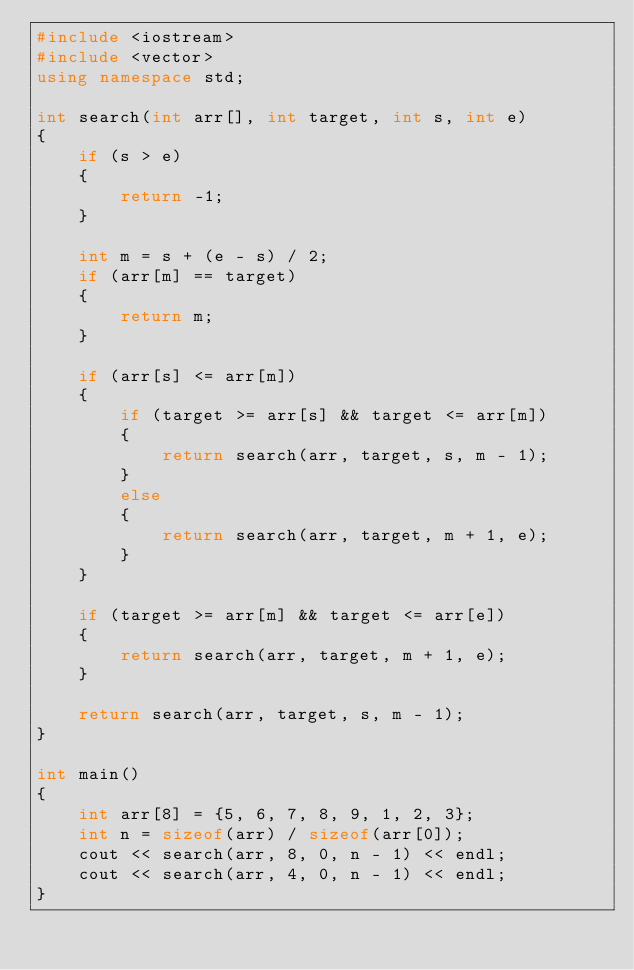<code> <loc_0><loc_0><loc_500><loc_500><_C++_>#include <iostream>
#include <vector>
using namespace std;

int search(int arr[], int target, int s, int e)
{
    if (s > e)
    {
        return -1;
    }

    int m = s + (e - s) / 2;
    if (arr[m] == target)
    {
        return m;
    }

    if (arr[s] <= arr[m])
    {
        if (target >= arr[s] && target <= arr[m])
        {
            return search(arr, target, s, m - 1);
        }
        else
        {
            return search(arr, target, m + 1, e);
        }
    }

    if (target >= arr[m] && target <= arr[e])
    {
        return search(arr, target, m + 1, e);
    }

    return search(arr, target, s, m - 1);
}

int main()
{
    int arr[8] = {5, 6, 7, 8, 9, 1, 2, 3};
    int n = sizeof(arr) / sizeof(arr[0]);
    cout << search(arr, 8, 0, n - 1) << endl;
    cout << search(arr, 4, 0, n - 1) << endl;
}
</code> 